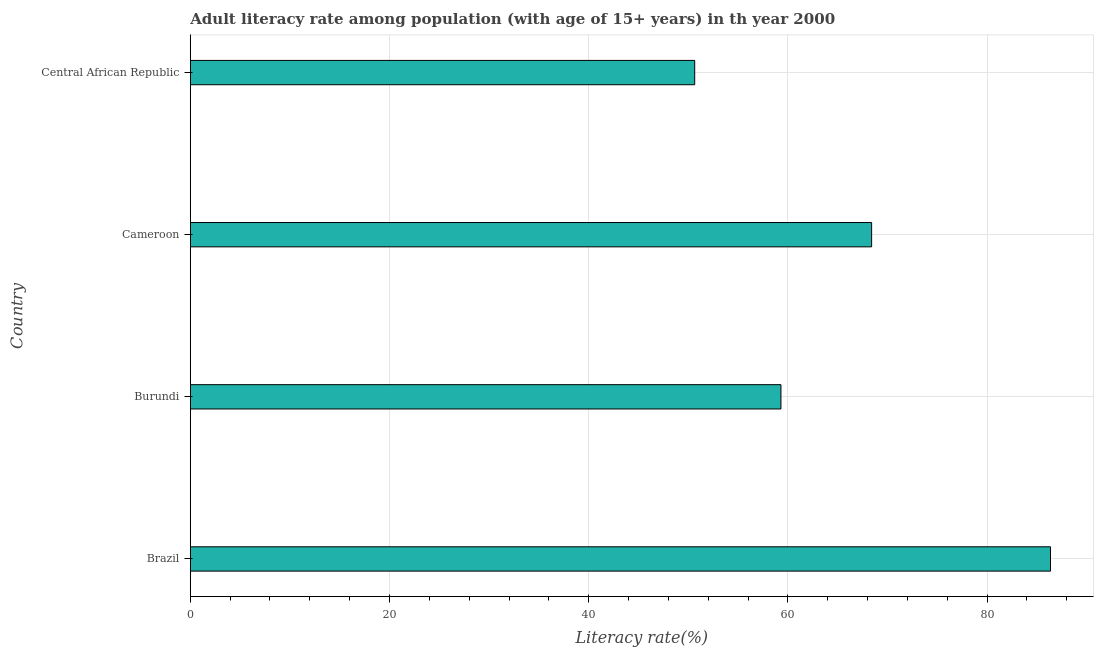Does the graph contain any zero values?
Your response must be concise. No. What is the title of the graph?
Keep it short and to the point. Adult literacy rate among population (with age of 15+ years) in th year 2000. What is the label or title of the X-axis?
Ensure brevity in your answer.  Literacy rate(%). What is the adult literacy rate in Burundi?
Your answer should be very brief. 59.3. Across all countries, what is the maximum adult literacy rate?
Provide a succinct answer. 86.37. Across all countries, what is the minimum adult literacy rate?
Provide a short and direct response. 50.65. In which country was the adult literacy rate maximum?
Provide a succinct answer. Brazil. In which country was the adult literacy rate minimum?
Give a very brief answer. Central African Republic. What is the sum of the adult literacy rate?
Keep it short and to the point. 264.73. What is the difference between the adult literacy rate in Brazil and Burundi?
Keep it short and to the point. 27.06. What is the average adult literacy rate per country?
Your answer should be compact. 66.18. What is the median adult literacy rate?
Your answer should be very brief. 63.86. What is the ratio of the adult literacy rate in Burundi to that in Central African Republic?
Your answer should be compact. 1.17. Is the adult literacy rate in Brazil less than that in Cameroon?
Offer a very short reply. No. What is the difference between the highest and the second highest adult literacy rate?
Provide a succinct answer. 17.96. What is the difference between the highest and the lowest adult literacy rate?
Your response must be concise. 35.72. What is the Literacy rate(%) in Brazil?
Keep it short and to the point. 86.37. What is the Literacy rate(%) of Burundi?
Offer a very short reply. 59.3. What is the Literacy rate(%) in Cameroon?
Keep it short and to the point. 68.41. What is the Literacy rate(%) of Central African Republic?
Provide a succinct answer. 50.65. What is the difference between the Literacy rate(%) in Brazil and Burundi?
Give a very brief answer. 27.06. What is the difference between the Literacy rate(%) in Brazil and Cameroon?
Make the answer very short. 17.96. What is the difference between the Literacy rate(%) in Brazil and Central African Republic?
Keep it short and to the point. 35.72. What is the difference between the Literacy rate(%) in Burundi and Cameroon?
Your response must be concise. -9.11. What is the difference between the Literacy rate(%) in Burundi and Central African Republic?
Provide a short and direct response. 8.66. What is the difference between the Literacy rate(%) in Cameroon and Central African Republic?
Offer a terse response. 17.76. What is the ratio of the Literacy rate(%) in Brazil to that in Burundi?
Offer a very short reply. 1.46. What is the ratio of the Literacy rate(%) in Brazil to that in Cameroon?
Make the answer very short. 1.26. What is the ratio of the Literacy rate(%) in Brazil to that in Central African Republic?
Your response must be concise. 1.71. What is the ratio of the Literacy rate(%) in Burundi to that in Cameroon?
Ensure brevity in your answer.  0.87. What is the ratio of the Literacy rate(%) in Burundi to that in Central African Republic?
Your response must be concise. 1.17. What is the ratio of the Literacy rate(%) in Cameroon to that in Central African Republic?
Make the answer very short. 1.35. 